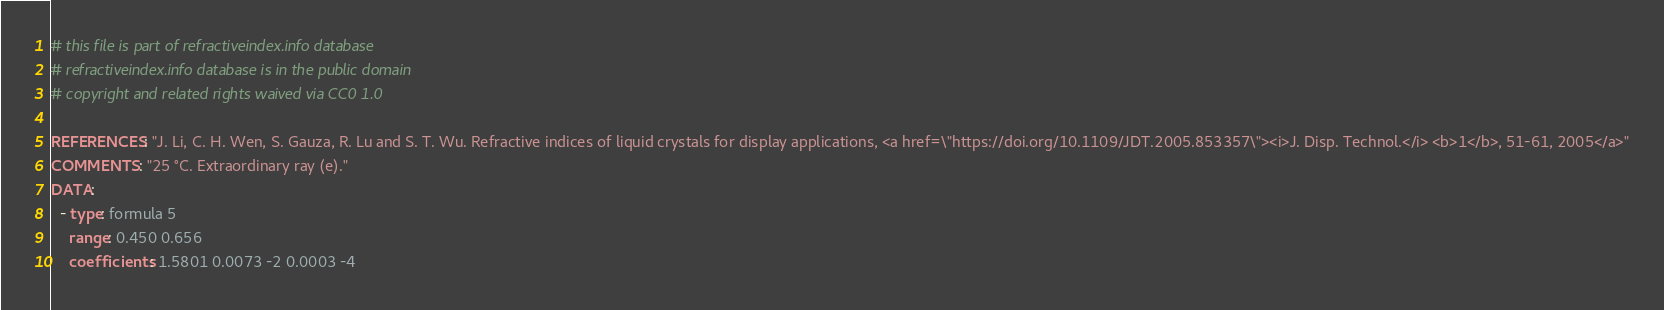Convert code to text. <code><loc_0><loc_0><loc_500><loc_500><_YAML_># this file is part of refractiveindex.info database
# refractiveindex.info database is in the public domain
# copyright and related rights waived via CC0 1.0

REFERENCES: "J. Li, C. H. Wen, S. Gauza, R. Lu and S. T. Wu. Refractive indices of liquid crystals for display applications, <a href=\"https://doi.org/10.1109/JDT.2005.853357\"><i>J. Disp. Technol.</i> <b>1</b>, 51-61, 2005</a>"
COMMENTS: "25 °C. Extraordinary ray (e)."
DATA:
  - type: formula 5
    range: 0.450 0.656
    coefficients: 1.5801 0.0073 -2 0.0003 -4</code> 